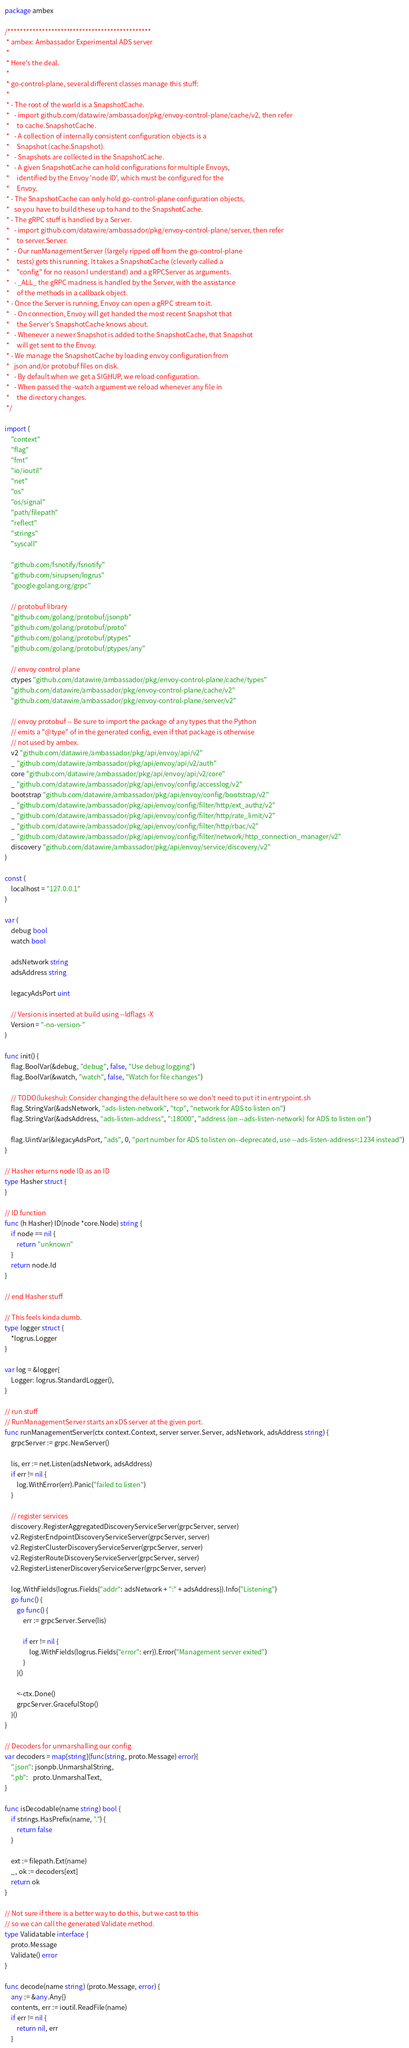<code> <loc_0><loc_0><loc_500><loc_500><_Go_>package ambex

/**********************************************
 * ambex: Ambassador Experimental ADS server
 *
 * Here's the deal.
 *
 * go-control-plane, several different classes manage this stuff:
 *
 * - The root of the world is a SnapshotCache.
 *   - import github.com/datawire/ambassador/pkg/envoy-control-plane/cache/v2, then refer
 *     to cache.SnapshotCache.
 *   - A collection of internally consistent configuration objects is a
 *     Snapshot (cache.Snapshot).
 *   - Snapshots are collected in the SnapshotCache.
 *   - A given SnapshotCache can hold configurations for multiple Envoys,
 *     identified by the Envoy 'node ID', which must be configured for the
 *     Envoy.
 * - The SnapshotCache can only hold go-control-plane configuration objects,
 *   so you have to build these up to hand to the SnapshotCache.
 * - The gRPC stuff is handled by a Server.
 *   - import github.com/datawire/ambassador/pkg/envoy-control-plane/server, then refer
 *     to server.Server.
 *   - Our runManagementServer (largely ripped off from the go-control-plane
 *     tests) gets this running. It takes a SnapshotCache (cleverly called a
 *     "config" for no reason I understand) and a gRPCServer as arguments.
 *   - _ALL_ the gRPC madness is handled by the Server, with the assistance
 *     of the methods in a callback object.
 * - Once the Server is running, Envoy can open a gRPC stream to it.
 *   - On connection, Envoy will get handed the most recent Snapshot that
 *     the Server's SnapshotCache knows about.
 *   - Whenever a newer Snapshot is added to the SnapshotCache, that Snapshot
 *     will get sent to the Envoy.
 * - We manage the SnapshotCache by loading envoy configuration from
 *   json and/or protobuf files on disk.
 *   - By default when we get a SIGHUP, we reload configuration.
 *   - When passed the -watch argument we reload whenever any file in
 *     the directory changes.
 */

import (
	"context"
	"flag"
	"fmt"
	"io/ioutil"
	"net"
	"os"
	"os/signal"
	"path/filepath"
	"reflect"
	"strings"
	"syscall"

	"github.com/fsnotify/fsnotify"
	"github.com/sirupsen/logrus"
	"google.golang.org/grpc"

	// protobuf library
	"github.com/golang/protobuf/jsonpb"
	"github.com/golang/protobuf/proto"
	"github.com/golang/protobuf/ptypes"
	"github.com/golang/protobuf/ptypes/any"

	// envoy control plane
	ctypes "github.com/datawire/ambassador/pkg/envoy-control-plane/cache/types"
	"github.com/datawire/ambassador/pkg/envoy-control-plane/cache/v2"
	"github.com/datawire/ambassador/pkg/envoy-control-plane/server/v2"

	// envoy protobuf -- Be sure to import the package of any types that the Python
	// emits a "@type" of in the generated config, even if that package is otherwise
	// not used by ambex.
	v2 "github.com/datawire/ambassador/pkg/api/envoy/api/v2"
	_ "github.com/datawire/ambassador/pkg/api/envoy/api/v2/auth"
	core "github.com/datawire/ambassador/pkg/api/envoy/api/v2/core"
	_ "github.com/datawire/ambassador/pkg/api/envoy/config/accesslog/v2"
	bootstrap "github.com/datawire/ambassador/pkg/api/envoy/config/bootstrap/v2"
	_ "github.com/datawire/ambassador/pkg/api/envoy/config/filter/http/ext_authz/v2"
	_ "github.com/datawire/ambassador/pkg/api/envoy/config/filter/http/rate_limit/v2"
	_ "github.com/datawire/ambassador/pkg/api/envoy/config/filter/http/rbac/v2"
	_ "github.com/datawire/ambassador/pkg/api/envoy/config/filter/network/http_connection_manager/v2"
	discovery "github.com/datawire/ambassador/pkg/api/envoy/service/discovery/v2"
)

const (
	localhost = "127.0.0.1"
)

var (
	debug bool
	watch bool

	adsNetwork string
	adsAddress string

	legacyAdsPort uint

	// Version is inserted at build using --ldflags -X
	Version = "-no-version-"
)

func init() {
	flag.BoolVar(&debug, "debug", false, "Use debug logging")
	flag.BoolVar(&watch, "watch", false, "Watch for file changes")

	// TODO(lukeshu): Consider changing the default here so we don't need to put it in entrypoint.sh
	flag.StringVar(&adsNetwork, "ads-listen-network", "tcp", "network for ADS to listen on")
	flag.StringVar(&adsAddress, "ads-listen-address", ":18000", "address (on --ads-listen-network) for ADS to listen on")

	flag.UintVar(&legacyAdsPort, "ads", 0, "port number for ADS to listen on--deprecated, use --ads-listen-address=:1234 instead")
}

// Hasher returns node ID as an ID
type Hasher struct {
}

// ID function
func (h Hasher) ID(node *core.Node) string {
	if node == nil {
		return "unknown"
	}
	return node.Id
}

// end Hasher stuff

// This feels kinda dumb.
type logger struct {
	*logrus.Logger
}

var log = &logger{
	Logger: logrus.StandardLogger(),
}

// run stuff
// RunManagementServer starts an xDS server at the given port.
func runManagementServer(ctx context.Context, server server.Server, adsNetwork, adsAddress string) {
	grpcServer := grpc.NewServer()

	lis, err := net.Listen(adsNetwork, adsAddress)
	if err != nil {
		log.WithError(err).Panic("failed to listen")
	}

	// register services
	discovery.RegisterAggregatedDiscoveryServiceServer(grpcServer, server)
	v2.RegisterEndpointDiscoveryServiceServer(grpcServer, server)
	v2.RegisterClusterDiscoveryServiceServer(grpcServer, server)
	v2.RegisterRouteDiscoveryServiceServer(grpcServer, server)
	v2.RegisterListenerDiscoveryServiceServer(grpcServer, server)

	log.WithFields(logrus.Fields{"addr": adsNetwork + ":" + adsAddress}).Info("Listening")
	go func() {
		go func() {
			err := grpcServer.Serve(lis)

			if err != nil {
				log.WithFields(logrus.Fields{"error": err}).Error("Management server exited")
			}
		}()

		<-ctx.Done()
		grpcServer.GracefulStop()
	}()
}

// Decoders for unmarshalling our config
var decoders = map[string](func(string, proto.Message) error){
	".json": jsonpb.UnmarshalString,
	".pb":   proto.UnmarshalText,
}

func isDecodable(name string) bool {
	if strings.HasPrefix(name, ".") {
		return false
	}

	ext := filepath.Ext(name)
	_, ok := decoders[ext]
	return ok
}

// Not sure if there is a better way to do this, but we cast to this
// so we can call the generated Validate method.
type Validatable interface {
	proto.Message
	Validate() error
}

func decode(name string) (proto.Message, error) {
	any := &any.Any{}
	contents, err := ioutil.ReadFile(name)
	if err != nil {
		return nil, err
	}
</code> 